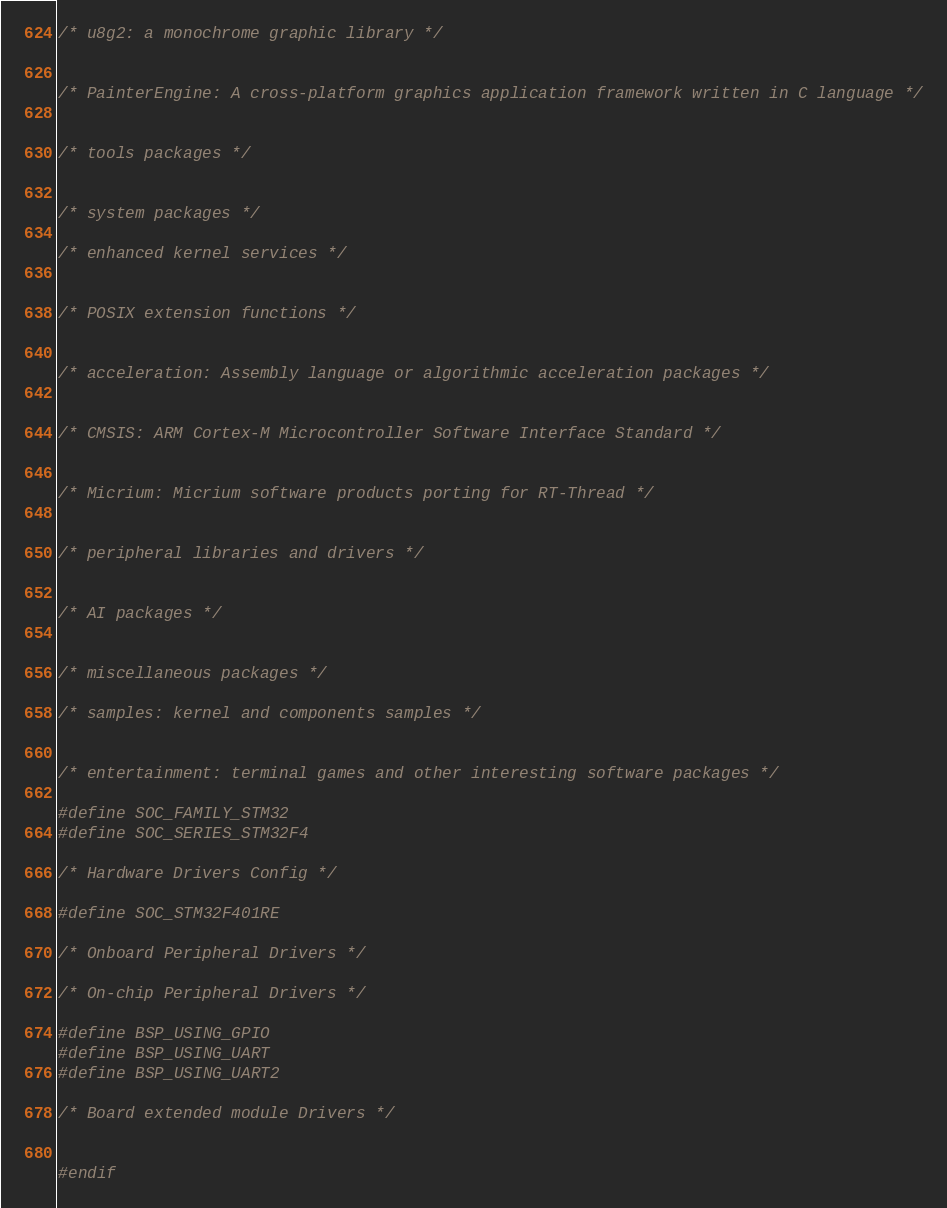Convert code to text. <code><loc_0><loc_0><loc_500><loc_500><_C_>/* u8g2: a monochrome graphic library */


/* PainterEngine: A cross-platform graphics application framework written in C language */


/* tools packages */


/* system packages */

/* enhanced kernel services */


/* POSIX extension functions */


/* acceleration: Assembly language or algorithmic acceleration packages */


/* CMSIS: ARM Cortex-M Microcontroller Software Interface Standard */


/* Micrium: Micrium software products porting for RT-Thread */


/* peripheral libraries and drivers */


/* AI packages */


/* miscellaneous packages */

/* samples: kernel and components samples */


/* entertainment: terminal games and other interesting software packages */

#define SOC_FAMILY_STM32
#define SOC_SERIES_STM32F4

/* Hardware Drivers Config */

#define SOC_STM32F401RE

/* Onboard Peripheral Drivers */

/* On-chip Peripheral Drivers */

#define BSP_USING_GPIO
#define BSP_USING_UART
#define BSP_USING_UART2

/* Board extended module Drivers */


#endif
</code> 